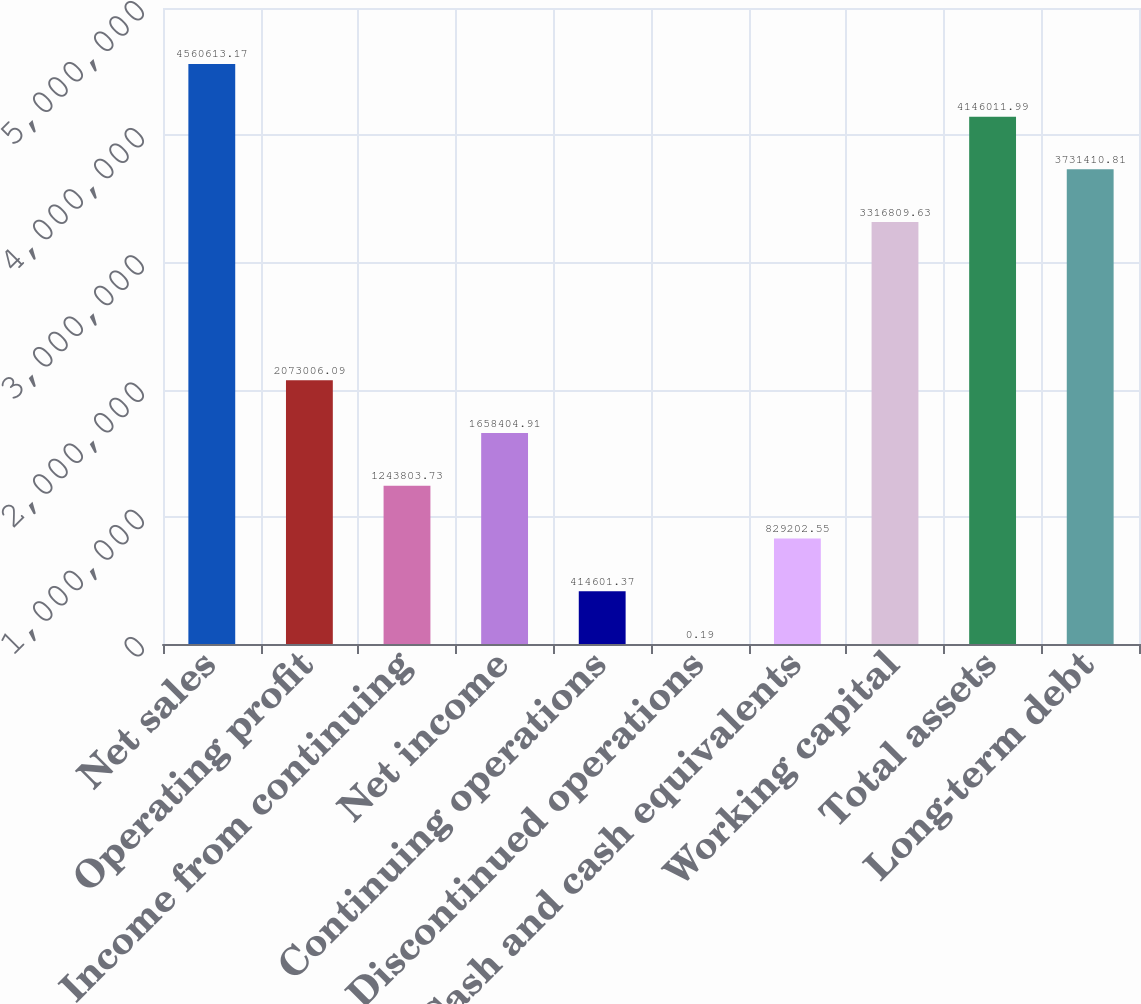Convert chart. <chart><loc_0><loc_0><loc_500><loc_500><bar_chart><fcel>Net sales<fcel>Operating profit<fcel>Income from continuing<fcel>Net income<fcel>Continuing operations<fcel>Discontinued operations<fcel>Cash and cash equivalents<fcel>Working capital<fcel>Total assets<fcel>Long-term debt<nl><fcel>4.56061e+06<fcel>2.07301e+06<fcel>1.2438e+06<fcel>1.6584e+06<fcel>414601<fcel>0.19<fcel>829203<fcel>3.31681e+06<fcel>4.14601e+06<fcel>3.73141e+06<nl></chart> 